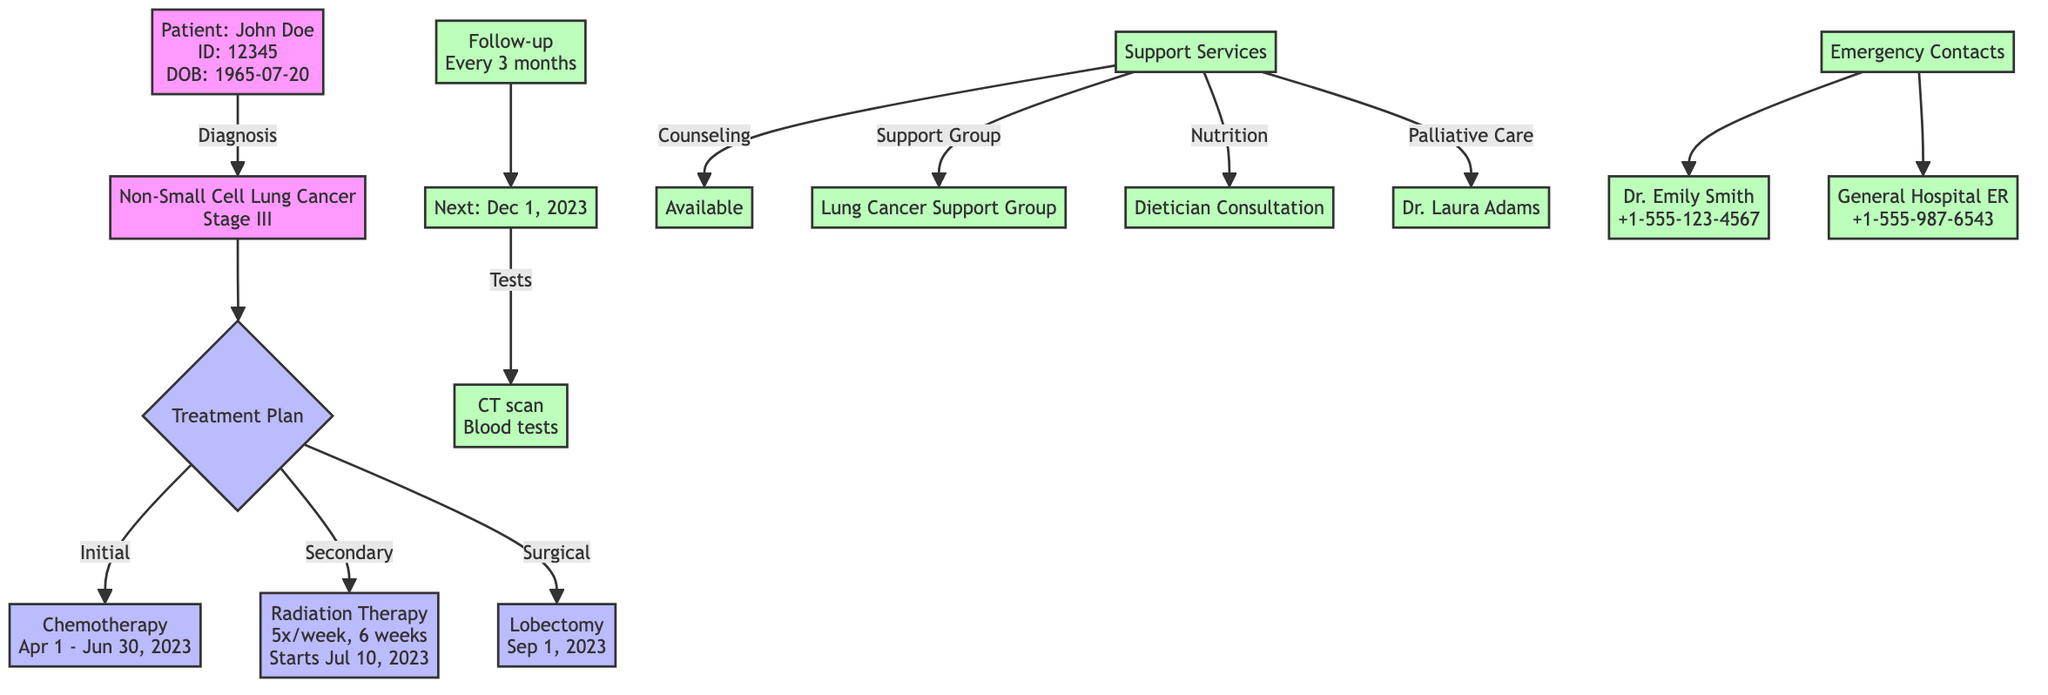What is the type of cancer diagnosed for the patient? The diagram shows the diagnosis node which indicates the patient's cancer type as "Non-Small Cell Lung Cancer."
Answer: Non-Small Cell Lung Cancer Who is the primary oncologist for the patient? The diagram lists the patient identification node, specifically showing the primary oncologist as "Dr. Emily Smith."
Answer: Dr. Emily Smith When is the next follow-up date scheduled? In the follow-up node, it clearly states that the next follow-up date is "2023-12-01."
Answer: 2023-12-01 What type of initial treatment is being administered? The treatment plan section indicates the initial treatment is "Chemotherapy."
Answer: Chemotherapy How many times a week is the secondary treatment administered? The secondary treatment node specifies it will occur "5 times a week."
Answer: 5 times a week Which test is included in the follow-up monitoring? The follow-up node mentions "CT scan" as one of the tests performed during follow-up.
Answer: CT scan Who is responsible for palliative care in this treatment plan? The support services section indicates "Dr. Laura Adams" as the palliative care provider.
Answer: Dr. Laura Adams What is the scheduled date for the surgical intervention? The surgical intervention node specifies the date is "2023-09-01."
Answer: 2023-09-01 What is the goal of the treatment plan? The treatment plan section outlines the goal as "Shrink tumor size and manage symptoms."
Answer: Shrink tumor size and manage symptoms 